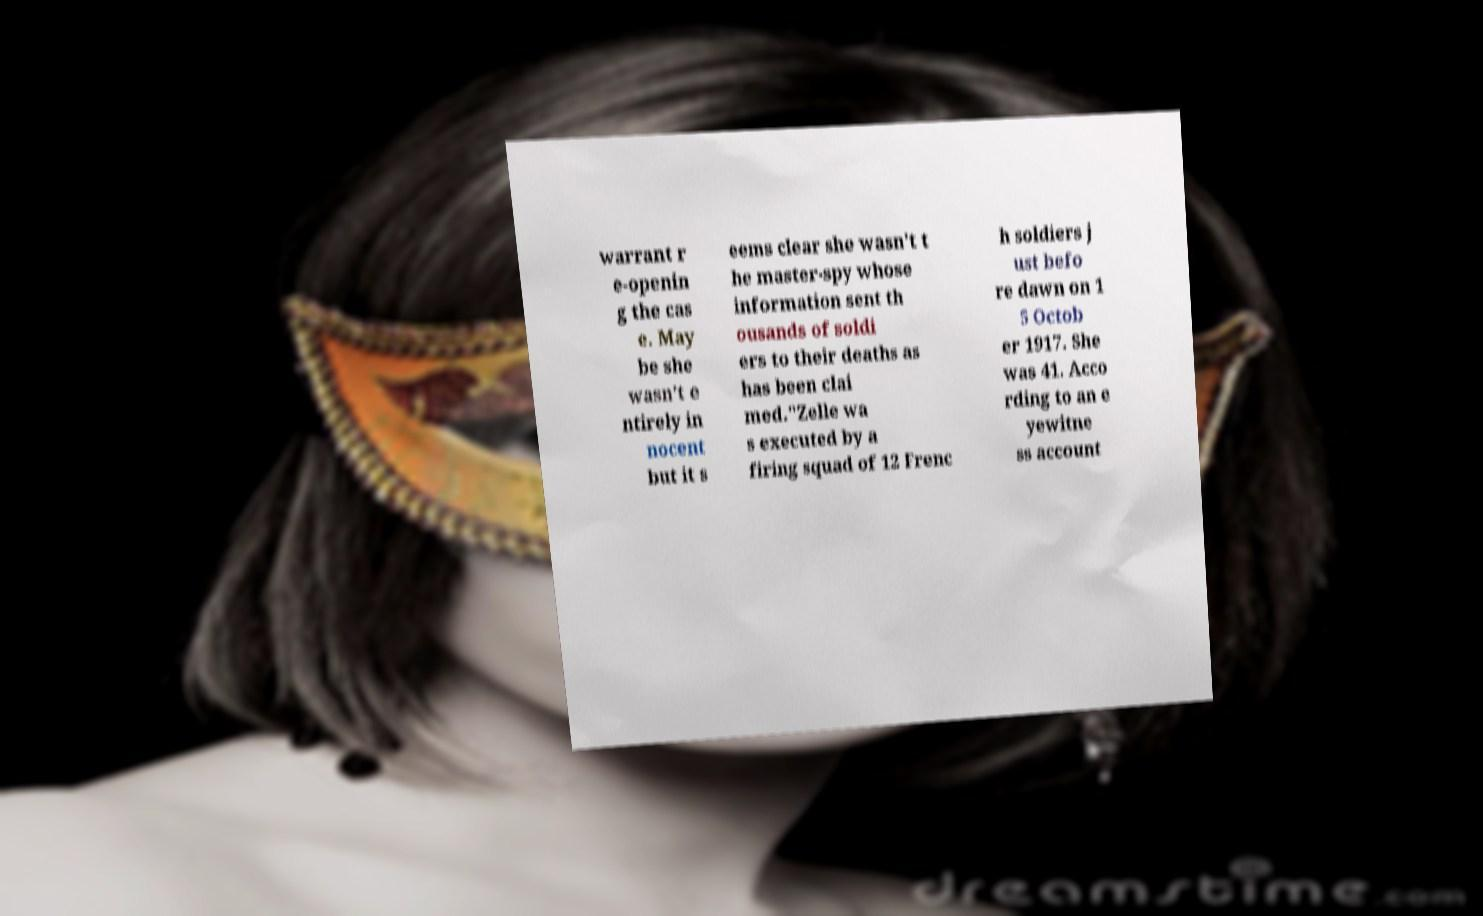Could you extract and type out the text from this image? warrant r e-openin g the cas e. May be she wasn't e ntirely in nocent but it s eems clear she wasn't t he master-spy whose information sent th ousands of soldi ers to their deaths as has been clai med."Zelle wa s executed by a firing squad of 12 Frenc h soldiers j ust befo re dawn on 1 5 Octob er 1917. She was 41. Acco rding to an e yewitne ss account 